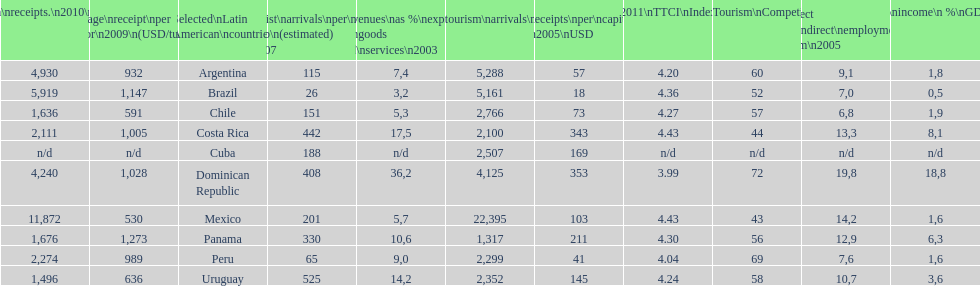Which latin american country had the largest number of tourism arrivals in 2010? Mexico. 